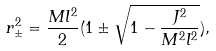Convert formula to latex. <formula><loc_0><loc_0><loc_500><loc_500>r _ { \pm } ^ { 2 } = \frac { M l ^ { 2 } } { 2 } ( 1 \pm \sqrt { 1 - \frac { J ^ { 2 } } { M ^ { 2 } l ^ { 2 } } } ) ,</formula> 